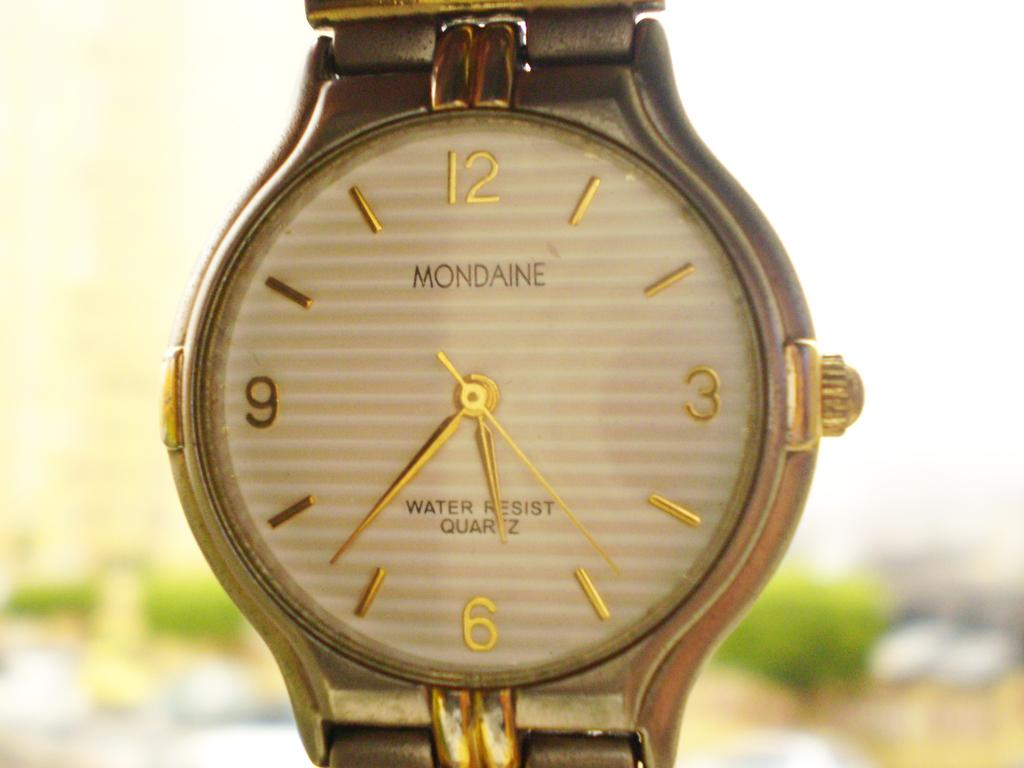<image>
Summarize the visual content of the image. A gold mondaine watch close up of the face. 